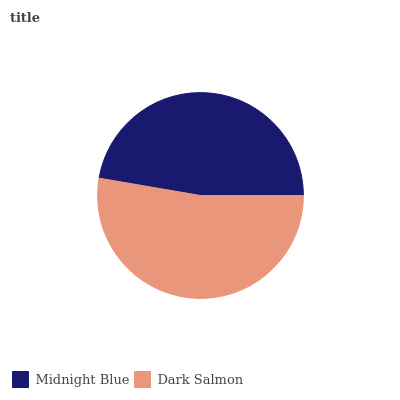Is Midnight Blue the minimum?
Answer yes or no. Yes. Is Dark Salmon the maximum?
Answer yes or no. Yes. Is Dark Salmon the minimum?
Answer yes or no. No. Is Dark Salmon greater than Midnight Blue?
Answer yes or no. Yes. Is Midnight Blue less than Dark Salmon?
Answer yes or no. Yes. Is Midnight Blue greater than Dark Salmon?
Answer yes or no. No. Is Dark Salmon less than Midnight Blue?
Answer yes or no. No. Is Dark Salmon the high median?
Answer yes or no. Yes. Is Midnight Blue the low median?
Answer yes or no. Yes. Is Midnight Blue the high median?
Answer yes or no. No. Is Dark Salmon the low median?
Answer yes or no. No. 